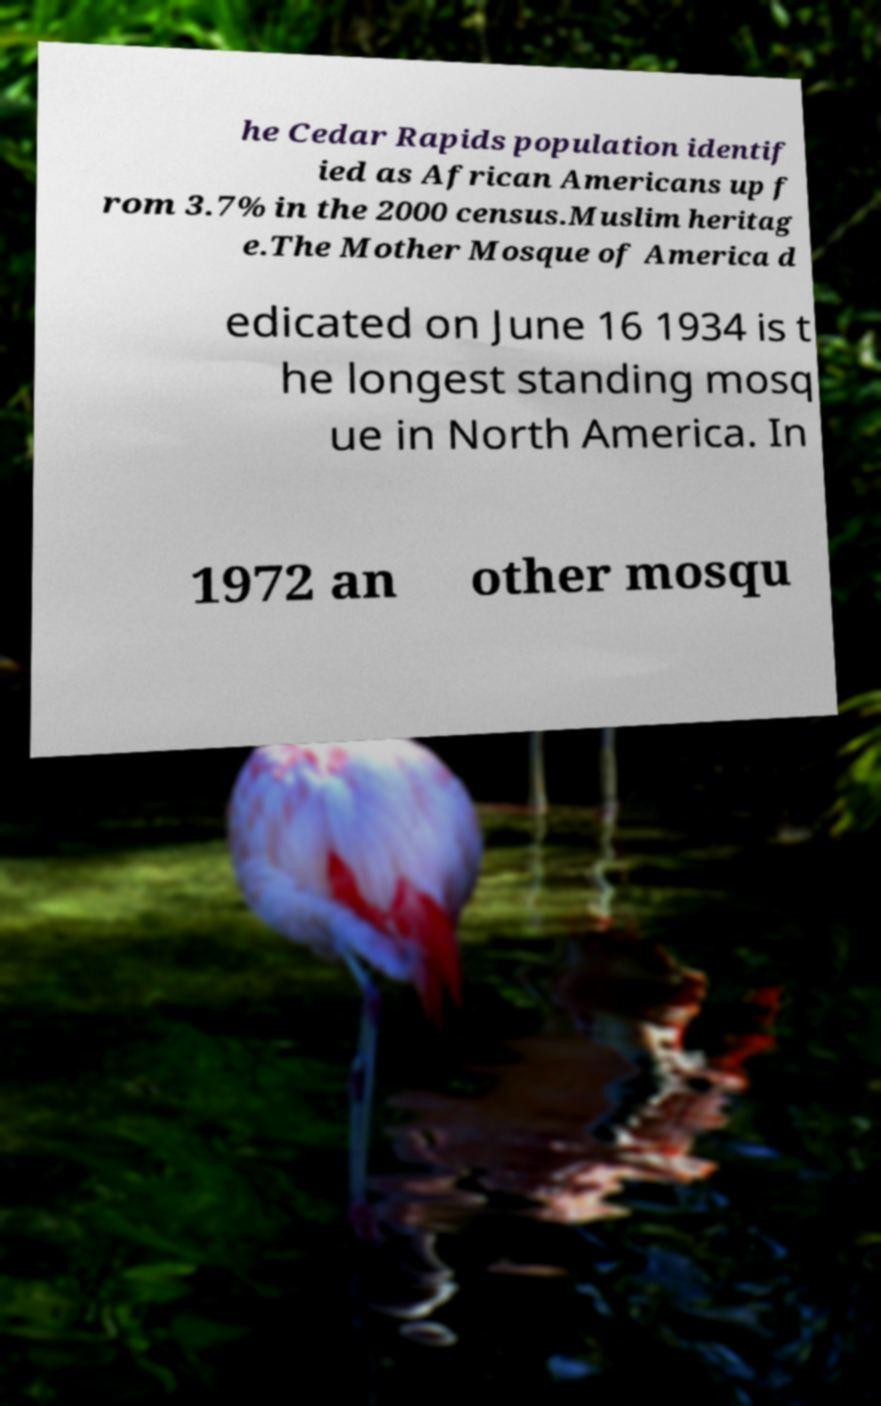Could you assist in decoding the text presented in this image and type it out clearly? he Cedar Rapids population identif ied as African Americans up f rom 3.7% in the 2000 census.Muslim heritag e.The Mother Mosque of America d edicated on June 16 1934 is t he longest standing mosq ue in North America. In 1972 an other mosqu 